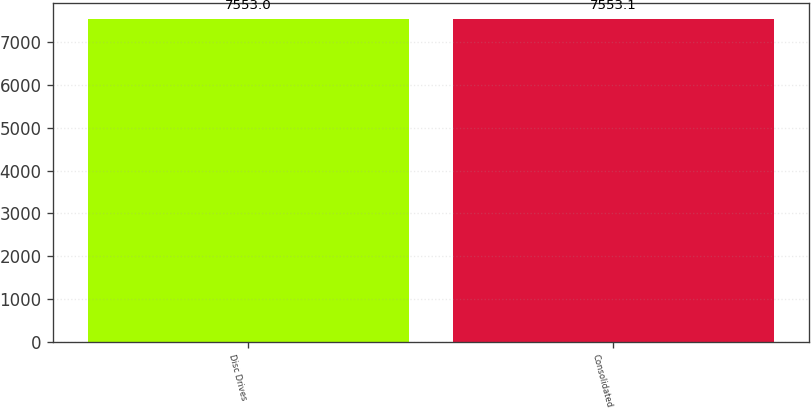Convert chart to OTSL. <chart><loc_0><loc_0><loc_500><loc_500><bar_chart><fcel>Disc Drives<fcel>Consolidated<nl><fcel>7553<fcel>7553.1<nl></chart> 